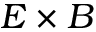<formula> <loc_0><loc_0><loc_500><loc_500>E \times B</formula> 